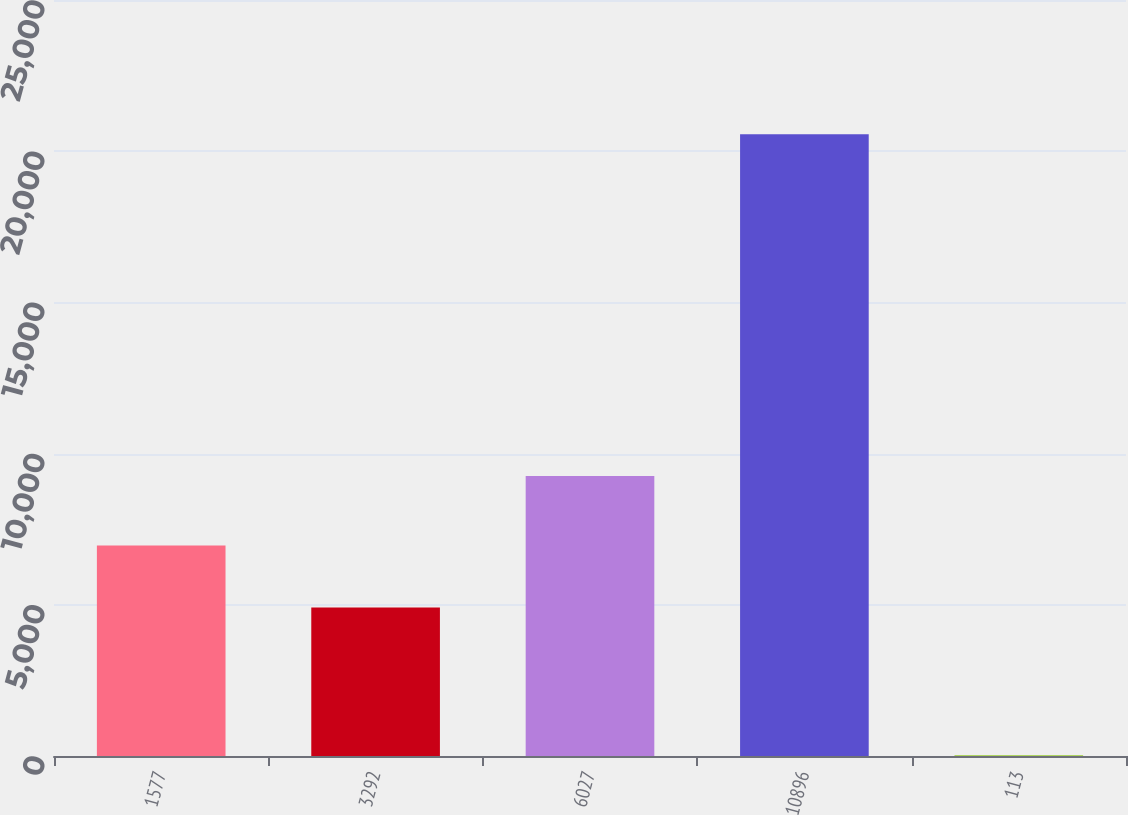Convert chart. <chart><loc_0><loc_0><loc_500><loc_500><bar_chart><fcel>1577<fcel>3292<fcel>6027<fcel>10896<fcel>113<nl><fcel>6960.77<fcel>4907<fcel>9257<fcel>20559<fcel>21.3<nl></chart> 